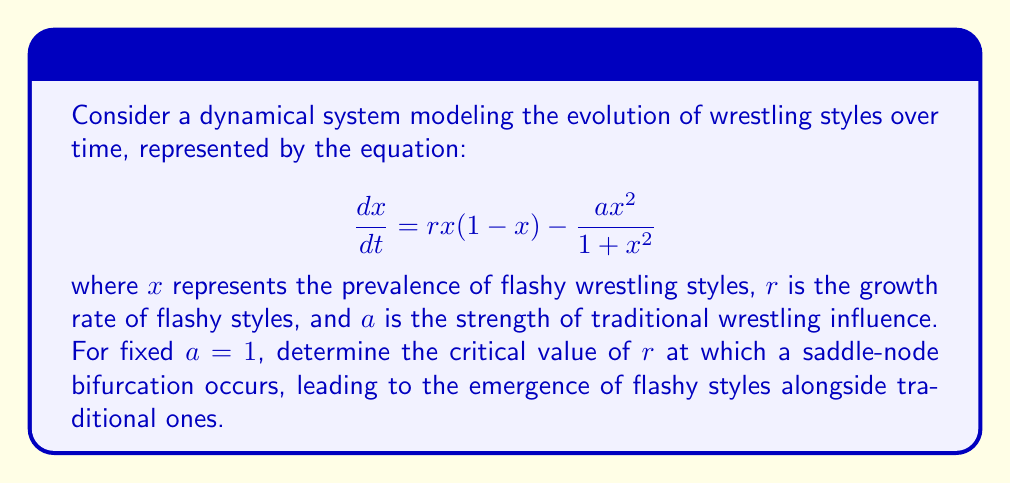Provide a solution to this math problem. To find the saddle-node bifurcation point, we need to follow these steps:

1) First, find the equilibrium points by setting $\frac{dx}{dt} = 0$:

   $$rx(1-x) - \frac{ax^2}{1+x^2} = 0$$

2) Rearrange the equation:

   $$rx(1-x)(1+x^2) = ax^2$$
   $$rx + rx^3 - rx^2 - rx^4 = ax^2$$
   $$rx + rx^3 - (r+a)x^2 - rx^4 = 0$$

3) For a saddle-node bifurcation, this equation should have a double root. This occurs when the equation and its derivative are simultaneously zero. The derivative is:

   $$r + 3rx^2 - 2(r+a)x - 4rx^3 = 0$$

4) At the bifurcation point, both equations are satisfied for the same $x$ value. Divide the original equation by $x$ (assuming $x \neq 0$):

   $$r + rx^2 - (r+a)x - rx^3 = 0$$

5) Now we have two equations that should be identical at the bifurcation point. Comparing coefficients:

   $r = r$ (trivial)
   $3rx^2 = rx^2$
   $-2(r+a)x = -(r+a)x$
   $-4rx^3 = -rx^3$

6) From the last equation: $4rx^3 = rx^3$, which implies $x=\frac{1}{\sqrt{3}}$ at the bifurcation point.

7) Substitute this back into either equation. Using the simpler one:

   $$r + r(\frac{1}{3}) - (r+a)(\frac{1}{\sqrt{3}}) - r(\frac{1}{3\sqrt{3}}) = 0$$

8) Simplify, remembering that $a=1$:

   $$\frac{4r}{3} - \frac{r+1}{\sqrt{3}} - \frac{r}{3\sqrt{3}} = 0$$

9) Multiply by $3\sqrt{3}$:

   $$4r\sqrt{3} - 3(r+1) - r = 0$$
   $$4r\sqrt{3} - 4r - 3 = 0$$

10) Solve for $r$:

    $$r(4\sqrt{3} - 4) = 3$$
    $$r = \frac{3}{4\sqrt{3} - 4}$$
Answer: $r = \frac{3}{4\sqrt{3} - 4}$ 